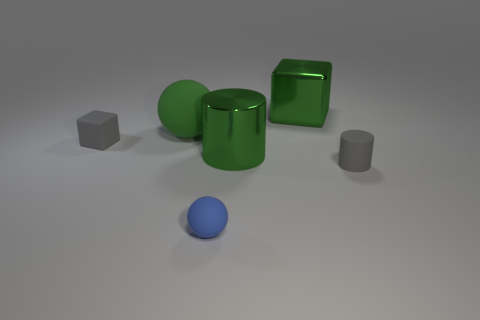Add 3 rubber spheres. How many objects exist? 9 Add 5 purple metallic cylinders. How many purple metallic cylinders exist? 5 Subtract 0 cyan balls. How many objects are left? 6 Subtract all blue metal objects. Subtract all small blue rubber objects. How many objects are left? 5 Add 6 blue things. How many blue things are left? 7 